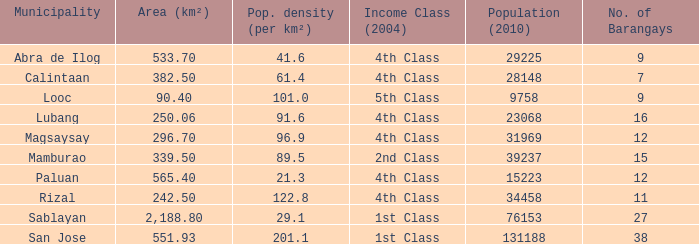List the population density per kilometer for the city of abra de ilog. 41.6. 